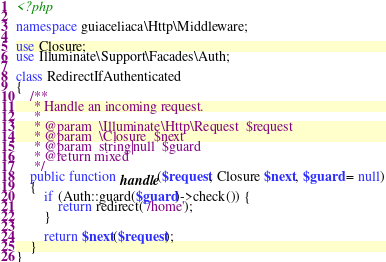Convert code to text. <code><loc_0><loc_0><loc_500><loc_500><_PHP_><?php

namespace guiaceliaca\Http\Middleware;

use Closure;
use Illuminate\Support\Facades\Auth;

class RedirectIfAuthenticated
{
    /**
     * Handle an incoming request.
     *
     * @param  \Illuminate\Http\Request  $request
     * @param  \Closure  $next
     * @param  string|null  $guard
     * @return mixed
     */
    public function handle($request, Closure $next, $guard = null)
    {
        if (Auth::guard($guard)->check()) {
            return redirect('/home');
        }

        return $next($request);
    }
}
</code> 